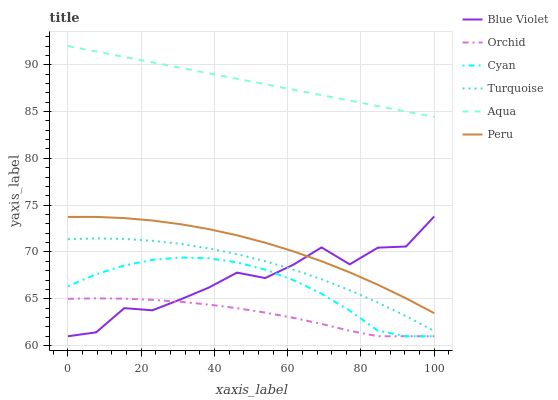Does Orchid have the minimum area under the curve?
Answer yes or no. Yes. Does Aqua have the maximum area under the curve?
Answer yes or no. Yes. Does Peru have the minimum area under the curve?
Answer yes or no. No. Does Peru have the maximum area under the curve?
Answer yes or no. No. Is Aqua the smoothest?
Answer yes or no. Yes. Is Blue Violet the roughest?
Answer yes or no. Yes. Is Peru the smoothest?
Answer yes or no. No. Is Peru the roughest?
Answer yes or no. No. Does Cyan have the lowest value?
Answer yes or no. Yes. Does Peru have the lowest value?
Answer yes or no. No. Does Aqua have the highest value?
Answer yes or no. Yes. Does Peru have the highest value?
Answer yes or no. No. Is Blue Violet less than Aqua?
Answer yes or no. Yes. Is Aqua greater than Blue Violet?
Answer yes or no. Yes. Does Blue Violet intersect Peru?
Answer yes or no. Yes. Is Blue Violet less than Peru?
Answer yes or no. No. Is Blue Violet greater than Peru?
Answer yes or no. No. Does Blue Violet intersect Aqua?
Answer yes or no. No. 